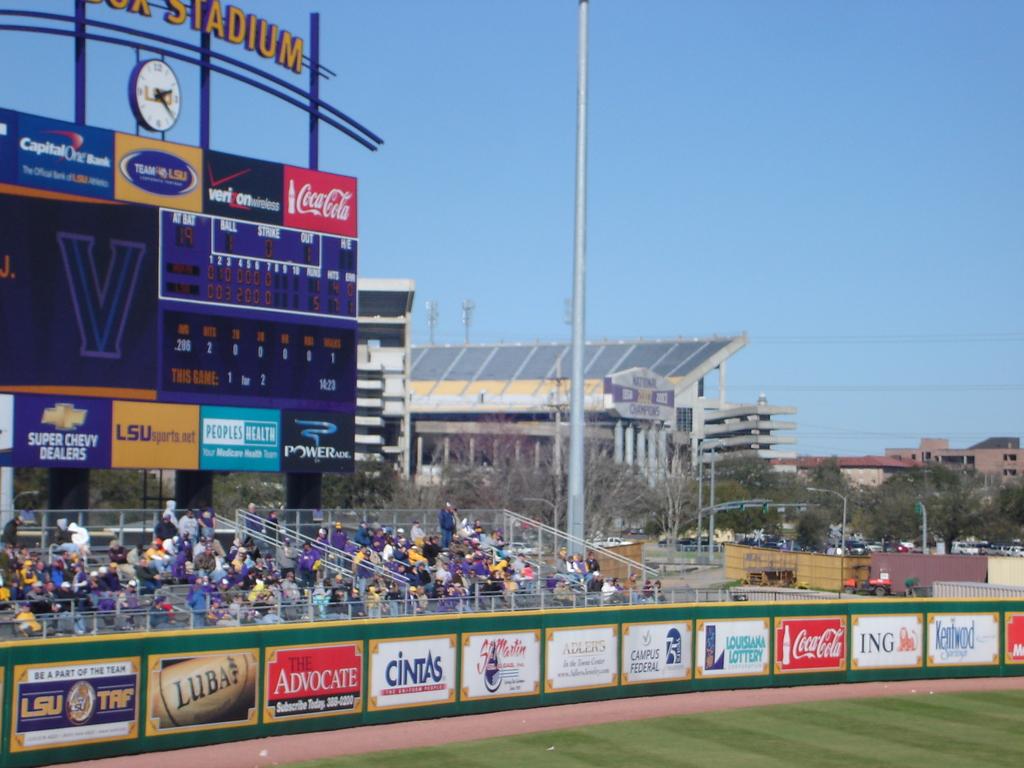What wireless carrier is advertised above the scoreboard?
Keep it short and to the point. Verizon. What brand of soda is shown in red?
Provide a succinct answer. Coca cola. 